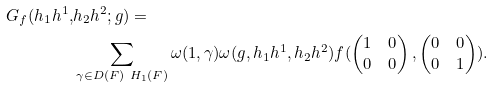Convert formula to latex. <formula><loc_0><loc_0><loc_500><loc_500>G _ { f } ( h _ { 1 } h ^ { 1 } , & h _ { 2 } h ^ { 2 } ; g ) = \\ & \sum _ { \gamma \in D ( F ) \ H _ { 1 } ( F ) } \omega ( 1 , \gamma ) \omega ( g , h _ { 1 } h ^ { 1 } , h _ { 2 } h ^ { 2 } ) f ( \begin{pmatrix} 1 & 0 \\ 0 & 0 \end{pmatrix} , \begin{pmatrix} 0 & 0 \\ 0 & 1 \end{pmatrix} ) .</formula> 